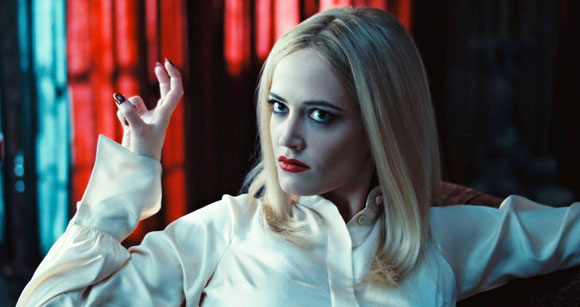Can you elaborate on the elements of the picture provided? In the image, we observe a woman seated on a luxurious red velvet couch, posing with an air of sophistication and enigma. She is dressed in a high-collared white blouse, which stands in stark contrast against the deep red backdrop of the couch. Her blond hair cascades in gentle waves, framing her face which is marked by striking red lipstick. The setting includes a suggestive play of lights that accentuates the dramatic atmosphere. Her expression and the styling evoke a narrative, perhaps hinting at a complex character in a dramatic storyline. 